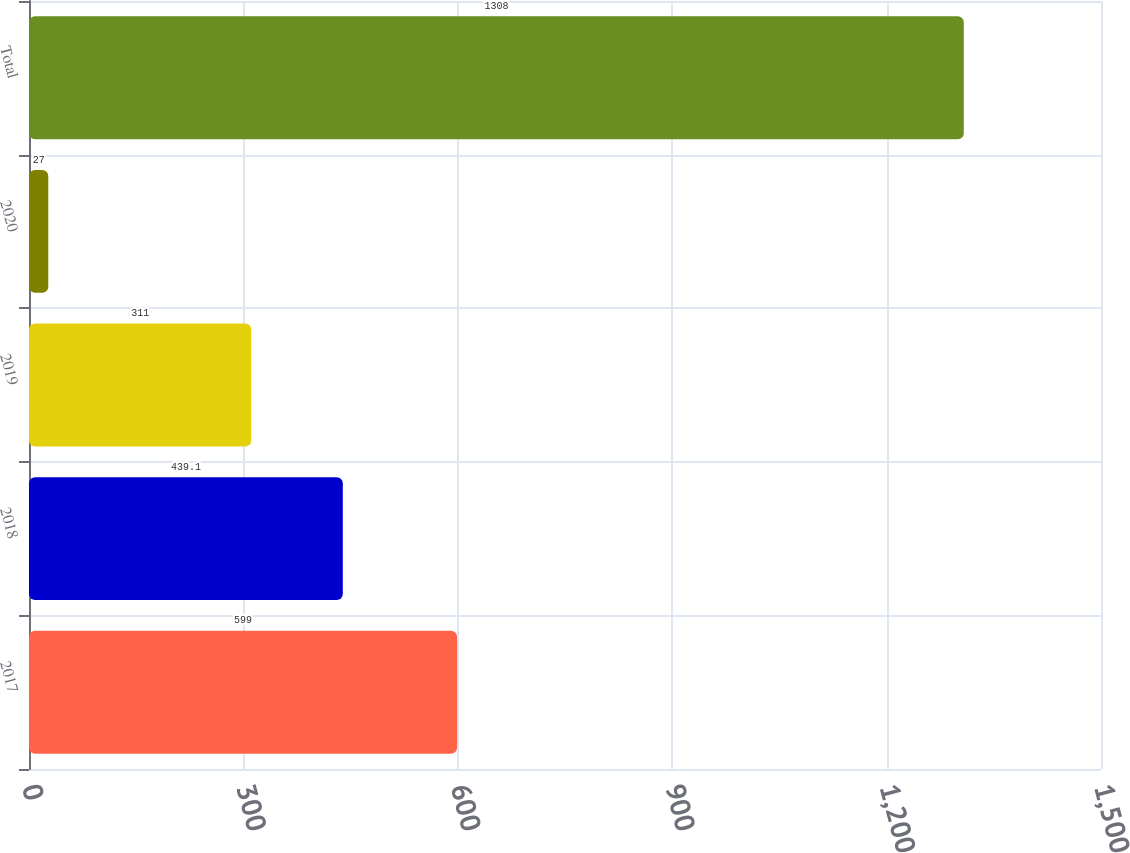<chart> <loc_0><loc_0><loc_500><loc_500><bar_chart><fcel>2017<fcel>2018<fcel>2019<fcel>2020<fcel>Total<nl><fcel>599<fcel>439.1<fcel>311<fcel>27<fcel>1308<nl></chart> 